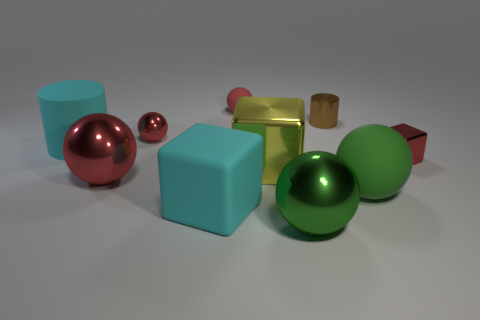Subtract all small metallic balls. How many balls are left? 4 How many red balls must be subtracted to get 2 red balls? 1 Subtract all cylinders. How many objects are left? 8 Subtract all yellow balls. Subtract all purple blocks. How many balls are left? 5 Subtract all brown cubes. How many red balls are left? 3 Subtract all purple rubber objects. Subtract all green metallic spheres. How many objects are left? 9 Add 5 big green rubber balls. How many big green rubber balls are left? 6 Add 6 large green spheres. How many large green spheres exist? 8 Subtract all green spheres. How many spheres are left? 3 Subtract 0 blue blocks. How many objects are left? 10 